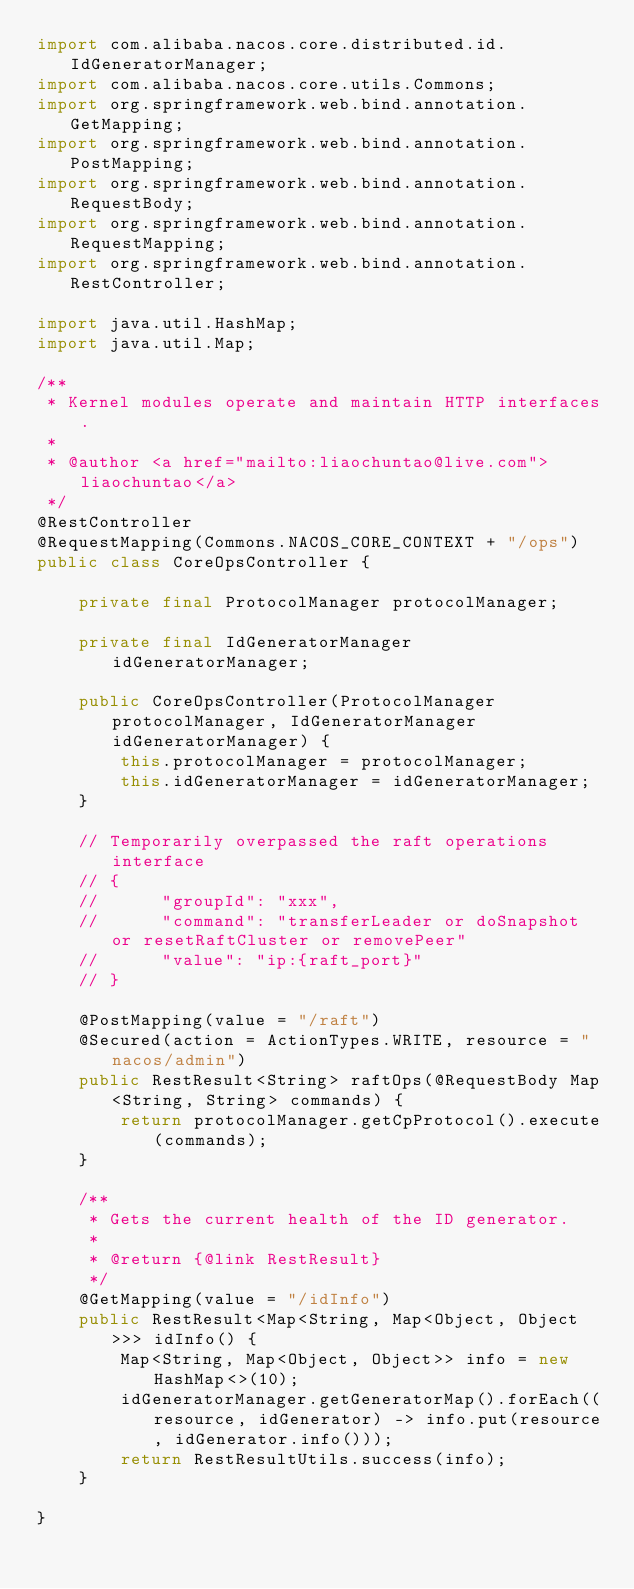Convert code to text. <code><loc_0><loc_0><loc_500><loc_500><_Java_>import com.alibaba.nacos.core.distributed.id.IdGeneratorManager;
import com.alibaba.nacos.core.utils.Commons;
import org.springframework.web.bind.annotation.GetMapping;
import org.springframework.web.bind.annotation.PostMapping;
import org.springframework.web.bind.annotation.RequestBody;
import org.springframework.web.bind.annotation.RequestMapping;
import org.springframework.web.bind.annotation.RestController;

import java.util.HashMap;
import java.util.Map;

/**
 * Kernel modules operate and maintain HTTP interfaces.
 *
 * @author <a href="mailto:liaochuntao@live.com">liaochuntao</a>
 */
@RestController
@RequestMapping(Commons.NACOS_CORE_CONTEXT + "/ops")
public class CoreOpsController {
    
    private final ProtocolManager protocolManager;
    
    private final IdGeneratorManager idGeneratorManager;
    
    public CoreOpsController(ProtocolManager protocolManager, IdGeneratorManager idGeneratorManager) {
        this.protocolManager = protocolManager;
        this.idGeneratorManager = idGeneratorManager;
    }
    
    // Temporarily overpassed the raft operations interface
    // {
    //      "groupId": "xxx",
    //      "command": "transferLeader or doSnapshot or resetRaftCluster or removePeer"
    //      "value": "ip:{raft_port}"
    // }
    
    @PostMapping(value = "/raft")
    @Secured(action = ActionTypes.WRITE, resource = "nacos/admin")
    public RestResult<String> raftOps(@RequestBody Map<String, String> commands) {
        return protocolManager.getCpProtocol().execute(commands);
    }
    
    /**
     * Gets the current health of the ID generator.
     *
     * @return {@link RestResult}
     */
    @GetMapping(value = "/idInfo")
    public RestResult<Map<String, Map<Object, Object>>> idInfo() {
        Map<String, Map<Object, Object>> info = new HashMap<>(10);
        idGeneratorManager.getGeneratorMap().forEach((resource, idGenerator) -> info.put(resource, idGenerator.info()));
        return RestResultUtils.success(info);
    }
    
}
</code> 